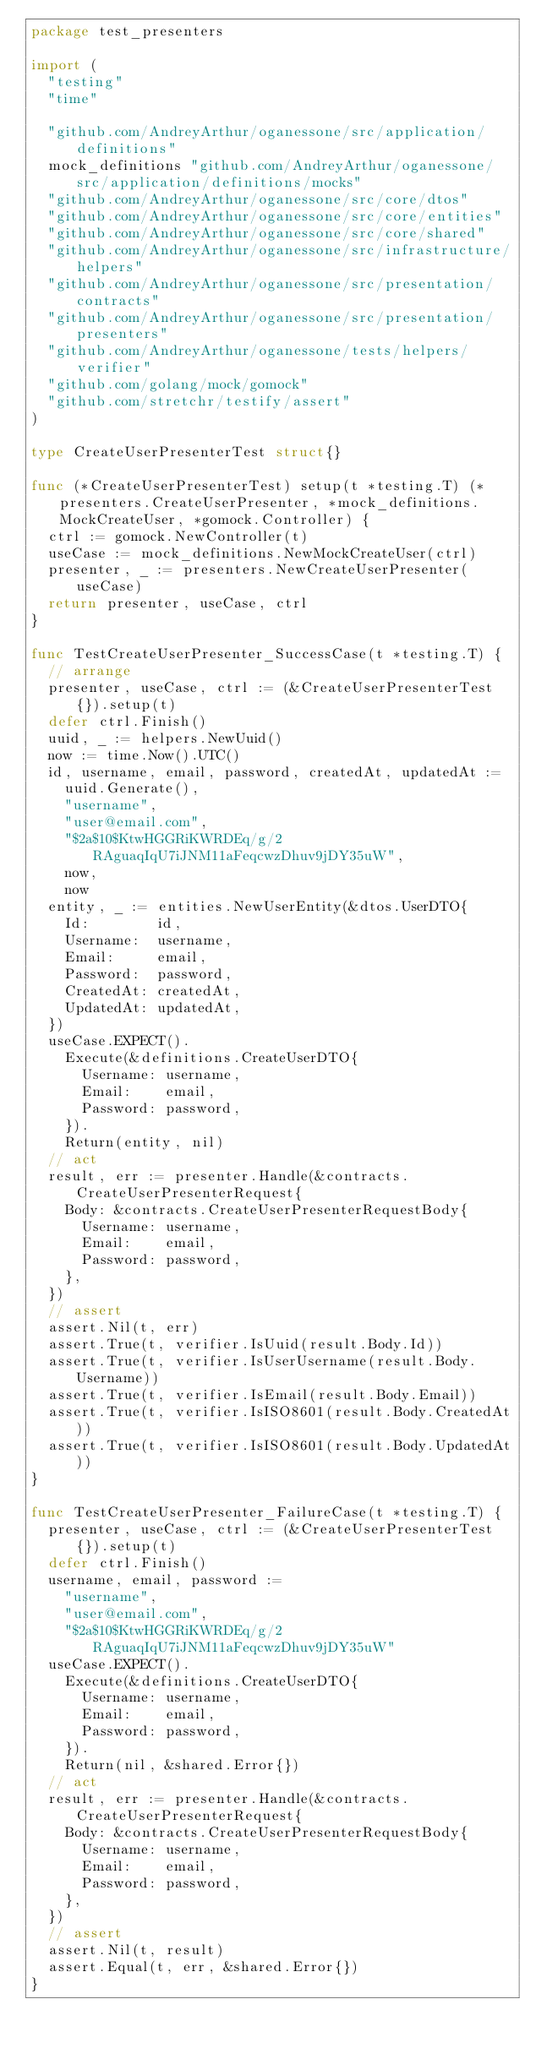Convert code to text. <code><loc_0><loc_0><loc_500><loc_500><_Go_>package test_presenters

import (
	"testing"
	"time"

	"github.com/AndreyArthur/oganessone/src/application/definitions"
	mock_definitions "github.com/AndreyArthur/oganessone/src/application/definitions/mocks"
	"github.com/AndreyArthur/oganessone/src/core/dtos"
	"github.com/AndreyArthur/oganessone/src/core/entities"
	"github.com/AndreyArthur/oganessone/src/core/shared"
	"github.com/AndreyArthur/oganessone/src/infrastructure/helpers"
	"github.com/AndreyArthur/oganessone/src/presentation/contracts"
	"github.com/AndreyArthur/oganessone/src/presentation/presenters"
	"github.com/AndreyArthur/oganessone/tests/helpers/verifier"
	"github.com/golang/mock/gomock"
	"github.com/stretchr/testify/assert"
)

type CreateUserPresenterTest struct{}

func (*CreateUserPresenterTest) setup(t *testing.T) (*presenters.CreateUserPresenter, *mock_definitions.MockCreateUser, *gomock.Controller) {
	ctrl := gomock.NewController(t)
	useCase := mock_definitions.NewMockCreateUser(ctrl)
	presenter, _ := presenters.NewCreateUserPresenter(useCase)
	return presenter, useCase, ctrl
}

func TestCreateUserPresenter_SuccessCase(t *testing.T) {
	// arrange
	presenter, useCase, ctrl := (&CreateUserPresenterTest{}).setup(t)
	defer ctrl.Finish()
	uuid, _ := helpers.NewUuid()
	now := time.Now().UTC()
	id, username, email, password, createdAt, updatedAt :=
		uuid.Generate(),
		"username",
		"user@email.com",
		"$2a$10$KtwHGGRiKWRDEq/g/2RAguaqIqU7iJNM11aFeqcwzDhuv9jDY35uW",
		now,
		now
	entity, _ := entities.NewUserEntity(&dtos.UserDTO{
		Id:        id,
		Username:  username,
		Email:     email,
		Password:  password,
		CreatedAt: createdAt,
		UpdatedAt: updatedAt,
	})
	useCase.EXPECT().
		Execute(&definitions.CreateUserDTO{
			Username: username,
			Email:    email,
			Password: password,
		}).
		Return(entity, nil)
	// act
	result, err := presenter.Handle(&contracts.CreateUserPresenterRequest{
		Body: &contracts.CreateUserPresenterRequestBody{
			Username: username,
			Email:    email,
			Password: password,
		},
	})
	// assert
	assert.Nil(t, err)
	assert.True(t, verifier.IsUuid(result.Body.Id))
	assert.True(t, verifier.IsUserUsername(result.Body.Username))
	assert.True(t, verifier.IsEmail(result.Body.Email))
	assert.True(t, verifier.IsISO8601(result.Body.CreatedAt))
	assert.True(t, verifier.IsISO8601(result.Body.UpdatedAt))
}

func TestCreateUserPresenter_FailureCase(t *testing.T) {
	presenter, useCase, ctrl := (&CreateUserPresenterTest{}).setup(t)
	defer ctrl.Finish()
	username, email, password :=
		"username",
		"user@email.com",
		"$2a$10$KtwHGGRiKWRDEq/g/2RAguaqIqU7iJNM11aFeqcwzDhuv9jDY35uW"
	useCase.EXPECT().
		Execute(&definitions.CreateUserDTO{
			Username: username,
			Email:    email,
			Password: password,
		}).
		Return(nil, &shared.Error{})
	// act
	result, err := presenter.Handle(&contracts.CreateUserPresenterRequest{
		Body: &contracts.CreateUserPresenterRequestBody{
			Username: username,
			Email:    email,
			Password: password,
		},
	})
	// assert
	assert.Nil(t, result)
	assert.Equal(t, err, &shared.Error{})
}
</code> 